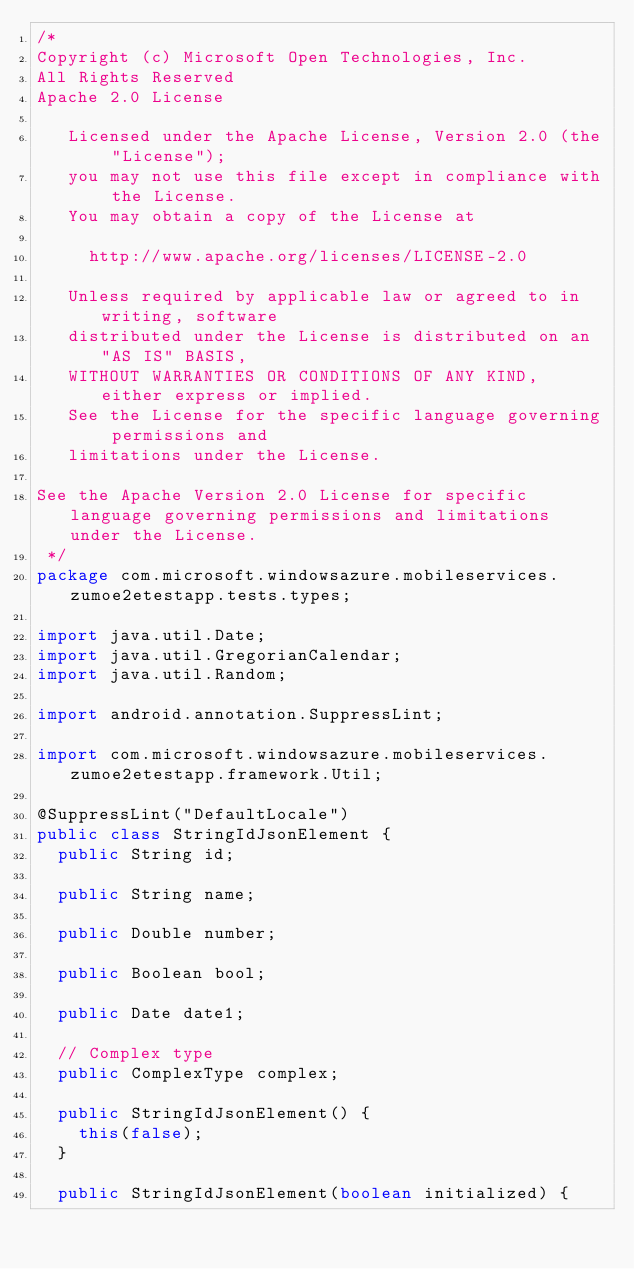<code> <loc_0><loc_0><loc_500><loc_500><_Java_>/*
Copyright (c) Microsoft Open Technologies, Inc.
All Rights Reserved
Apache 2.0 License
 
   Licensed under the Apache License, Version 2.0 (the "License");
   you may not use this file except in compliance with the License.
   You may obtain a copy of the License at
 
     http://www.apache.org/licenses/LICENSE-2.0
 
   Unless required by applicable law or agreed to in writing, software
   distributed under the License is distributed on an "AS IS" BASIS,
   WITHOUT WARRANTIES OR CONDITIONS OF ANY KIND, either express or implied.
   See the License for the specific language governing permissions and
   limitations under the License.
 
See the Apache Version 2.0 License for specific language governing permissions and limitations under the License.
 */
package com.microsoft.windowsazure.mobileservices.zumoe2etestapp.tests.types;

import java.util.Date;
import java.util.GregorianCalendar;
import java.util.Random;

import android.annotation.SuppressLint;

import com.microsoft.windowsazure.mobileservices.zumoe2etestapp.framework.Util;

@SuppressLint("DefaultLocale")
public class StringIdJsonElement {
	public String id;

	public String name;

	public Double number;

	public Boolean bool;

	public Date date1;

	// Complex type
	public ComplexType complex;

	public StringIdJsonElement() {
		this(false);
	}

	public StringIdJsonElement(boolean initialized) {</code> 